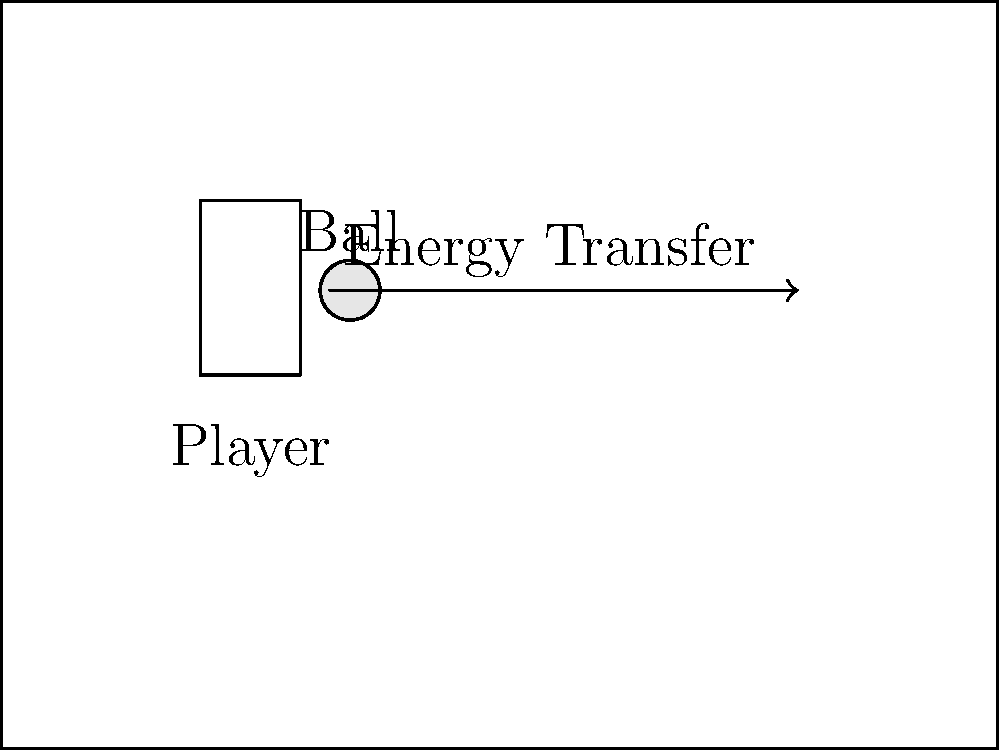During a chest pass in basketball, a player exerts a force of 50 N on the ball over a distance of 0.5 m. How much work is done by the player on the ball? Let's break this down step-by-step:

1. We know that work is defined as force multiplied by displacement in the direction of the force. The formula for work is:

   $W = F \cdot d$

   Where:
   $W$ = Work done
   $F$ = Force applied
   $d$ = Displacement

2. We are given:
   - Force (F) = 50 N
   - Displacement (d) = 0.5 m

3. Now, let's plug these values into our equation:

   $W = 50 \text{ N} \cdot 0.5 \text{ m}$

4. Multiply the numbers:

   $W = 25 \text{ N} \cdot \text{m}$

5. The unit N·m is equivalent to Joules (J), so we can express the final answer in Joules.

Therefore, the work done by the player on the ball during the chest pass is 25 J.
Answer: 25 J 